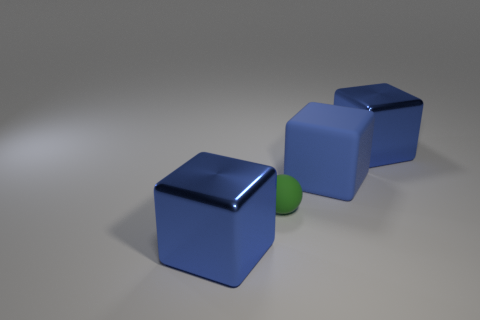Subtract all blue cubes. How many were subtracted if there are1blue cubes left? 2 Subtract all blue balls. Subtract all cyan cubes. How many balls are left? 1 Add 4 large blue objects. How many objects exist? 8 Subtract all spheres. How many objects are left? 3 Add 2 big green metallic cubes. How many big green metallic cubes exist? 2 Subtract 0 gray balls. How many objects are left? 4 Subtract all brown cylinders. Subtract all big blue metal things. How many objects are left? 2 Add 4 big blue matte blocks. How many big blue matte blocks are left? 5 